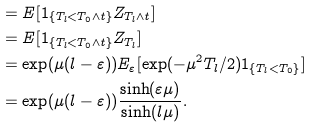<formula> <loc_0><loc_0><loc_500><loc_500>& = E [ 1 _ { \{ T _ { l } < T _ { 0 } \wedge t \} } Z _ { T _ { l } \wedge t } ] \\ & = E [ 1 _ { \{ T _ { l } < T _ { 0 } \wedge t \} } Z _ { T _ { l } } ] \\ & = \exp ( \mu ( l - \varepsilon ) ) E _ { \varepsilon } [ \exp ( - \mu ^ { 2 } T _ { l } / 2 ) 1 _ { \{ T _ { l } < T _ { 0 } \} } ] \\ & = \exp ( \mu ( l - \varepsilon ) ) \frac { \sinh ( \varepsilon \mu ) } { \sinh ( l \mu ) } .</formula> 